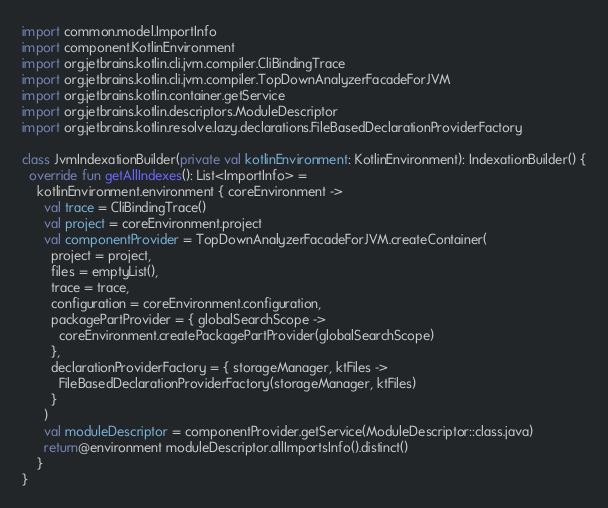<code> <loc_0><loc_0><loc_500><loc_500><_Kotlin_>import common.model.ImportInfo
import component.KotlinEnvironment
import org.jetbrains.kotlin.cli.jvm.compiler.CliBindingTrace
import org.jetbrains.kotlin.cli.jvm.compiler.TopDownAnalyzerFacadeForJVM
import org.jetbrains.kotlin.container.getService
import org.jetbrains.kotlin.descriptors.ModuleDescriptor
import org.jetbrains.kotlin.resolve.lazy.declarations.FileBasedDeclarationProviderFactory

class JvmIndexationBuilder(private val kotlinEnvironment: KotlinEnvironment): IndexationBuilder() {
  override fun getAllIndexes(): List<ImportInfo> =
    kotlinEnvironment.environment { coreEnvironment ->
      val trace = CliBindingTrace()
      val project = coreEnvironment.project
      val componentProvider = TopDownAnalyzerFacadeForJVM.createContainer(
        project = project,
        files = emptyList(),
        trace = trace,
        configuration = coreEnvironment.configuration,
        packagePartProvider = { globalSearchScope ->
          coreEnvironment.createPackagePartProvider(globalSearchScope)
        },
        declarationProviderFactory = { storageManager, ktFiles ->
          FileBasedDeclarationProviderFactory(storageManager, ktFiles)
        }
      )
      val moduleDescriptor = componentProvider.getService(ModuleDescriptor::class.java)
      return@environment moduleDescriptor.allImportsInfo().distinct()
    }
}
</code> 